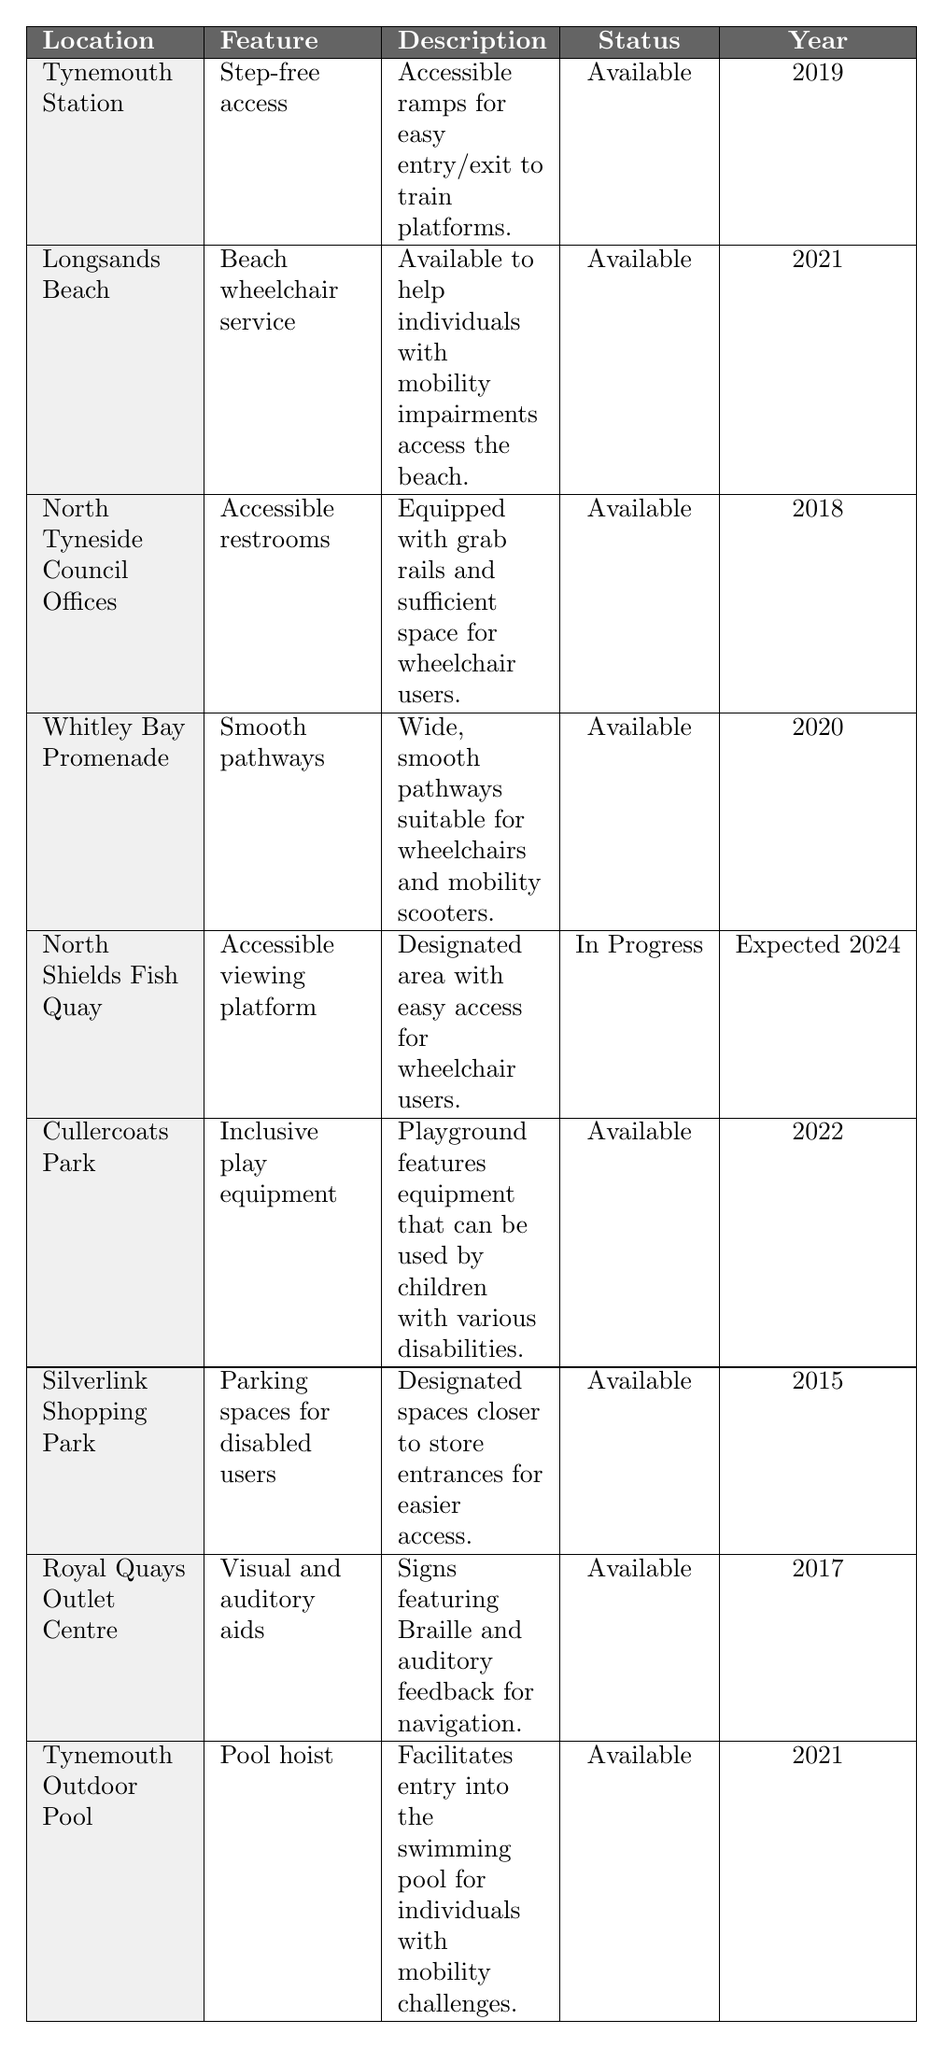What accessibility feature was implemented in Tynemouth Station? The table specifies that Tynemouth Station has "Step-free access" as its accessibility feature, which includes accessible ramps for easy entry and exit to train platforms.
Answer: Step-free access How many different locations have features available for people with disabilities? Counting the entries in the table, there are 8 locations listed with accessibility features that are marked as "Available."
Answer: 8 What year was the Accessible restrooms feature implemented at North Tyneside Council Offices? According to the table, the Accessible restrooms feature was implemented in 2018 at the North Tyneside Council Offices.
Answer: 2018 Is there a feature available for children with disabilities in Cullercoats Park? Yes, the table states that Cullercoats Park features inclusive play equipment that is designed for children with various disabilities, confirming that the feature is available.
Answer: Yes What is the latest year mentioned for an accessibility feature in progress, and what is the feature? The feature listed as "In Progress" is the Accessible viewing platform at North Shields Fish Quay, with an expected implementation year of 2024, making this the latest mention.
Answer: 2024; Accessible viewing platform How many features were implemented after 2020? Looking at the table, there are 3 features implemented after 2020: the Beach wheelchair service (2021), Inclusive play equipment (2022), and Pool hoist (2021). Therefore, the total number is 3.
Answer: 3 Which location has visual and auditory aids as an accessibility feature? The Royal Quays Outlet Centre is identified in the table as having visual and auditory aids, which include signs featuring Braille and auditory feedback for navigation.
Answer: Royal Quays Outlet Centre What percentage of the features listed are available based on the table? There are 8 features marked as "Available" and 9 total features listed in the table. To find the percentage, calculate (8/9) * 100, which equals approximately 88.89%.
Answer: Approximately 88.89% Which location has parking spaces designated for disabled users? The Silverlink Shopping Park is the location that has designated parking spaces for disabled users, according to the table.
Answer: Silverlink Shopping Park What is the common feature present in both Tynemouth Outdoor Pool and Longsands Beach? Both locations provide accessibility features aimed to support individuals with mobility challenges: Tynemouth Outdoor Pool has a pool hoist and Longsands Beach offers a beach wheelchair service.
Answer: Mobility support features 